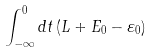Convert formula to latex. <formula><loc_0><loc_0><loc_500><loc_500>\int _ { - \infty } ^ { 0 } d t \left ( L + E _ { 0 } - \varepsilon _ { 0 } \right )</formula> 